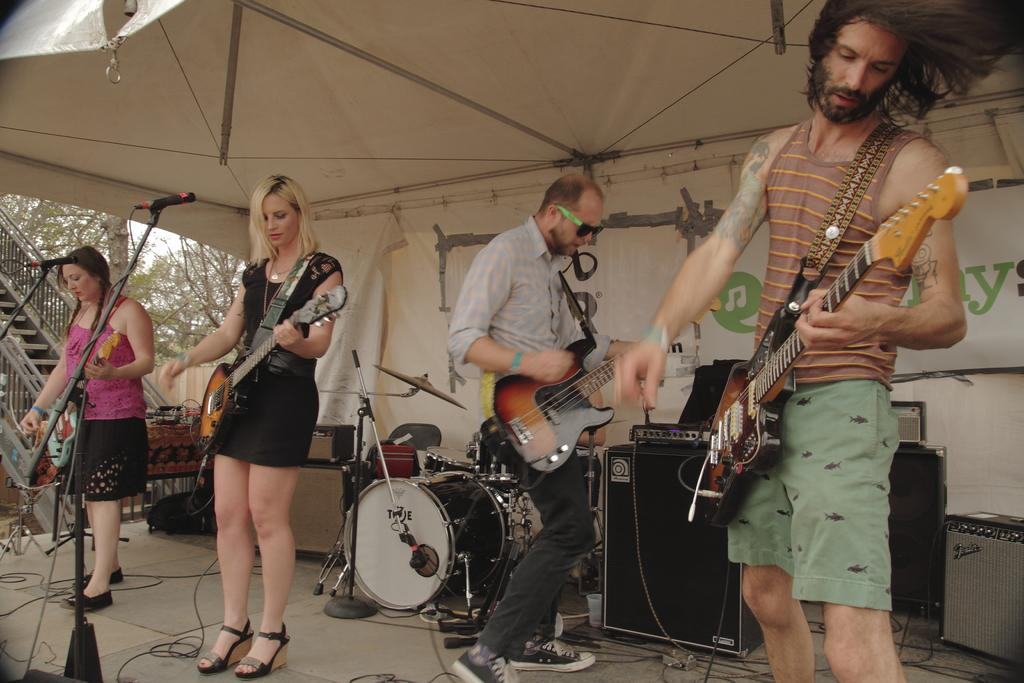How many people are in the image? There are four people in the image. Can you describe the gender of the people? Two of the people are men, and two are women. What are the people doing in the image? The people are playing guitars. Where are the people located in the image? They are on a dais. How many microphones are visible in the image? There are two microphones visible. What type of attraction can be seen in the image? There is no attraction present in the image; it features four people playing guitars on a dais. Can you describe the tail of the animal in the image? There is no animal, and therefore no tail, present in the image. 